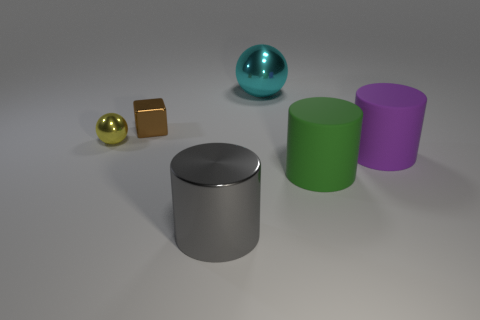Add 1 yellow metal spheres. How many objects exist? 7 Subtract all balls. How many objects are left? 4 Subtract all large blue cubes. Subtract all green matte things. How many objects are left? 5 Add 2 purple matte objects. How many purple matte objects are left? 3 Add 3 green matte cylinders. How many green matte cylinders exist? 4 Subtract 0 blue blocks. How many objects are left? 6 